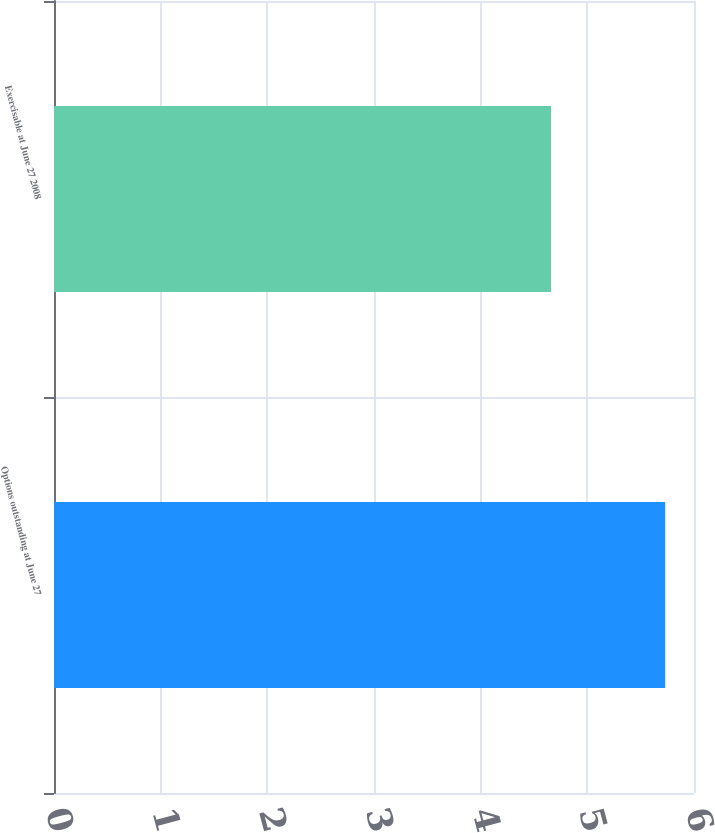Convert chart to OTSL. <chart><loc_0><loc_0><loc_500><loc_500><bar_chart><fcel>Options outstanding at June 27<fcel>Exercisable at June 27 2008<nl><fcel>5.73<fcel>4.66<nl></chart> 